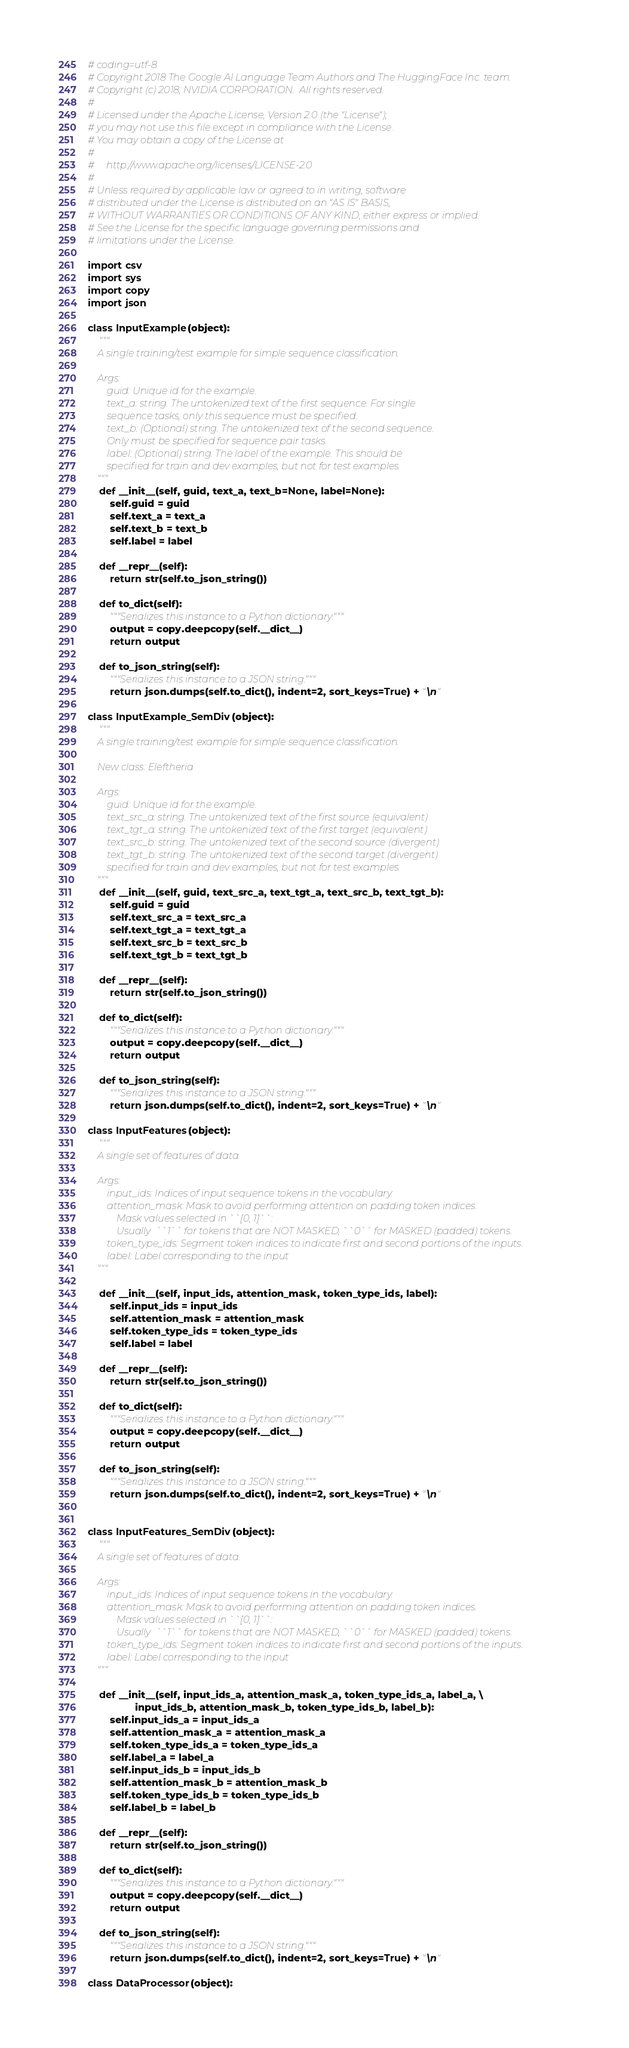<code> <loc_0><loc_0><loc_500><loc_500><_Python_># coding=utf-8
# Copyright 2018 The Google AI Language Team Authors and The HuggingFace Inc. team.
# Copyright (c) 2018, NVIDIA CORPORATION.  All rights reserved.
#
# Licensed under the Apache License, Version 2.0 (the "License");
# you may not use this file except in compliance with the License.
# You may obtain a copy of the License at
#
#     http://www.apache.org/licenses/LICENSE-2.0
#
# Unless required by applicable law or agreed to in writing, software
# distributed under the License is distributed on an "AS IS" BASIS,
# WITHOUT WARRANTIES OR CONDITIONS OF ANY KIND, either express or implied.
# See the License for the specific language governing permissions and
# limitations under the License.

import csv
import sys
import copy
import json

class InputExample(object):
    """
    A single training/test example for simple sequence classification.

    Args:
        guid: Unique id for the example.
        text_a: string. The untokenized text of the first sequence. For single
        sequence tasks, only this sequence must be specified.
        text_b: (Optional) string. The untokenized text of the second sequence.
        Only must be specified for sequence pair tasks.
        label: (Optional) string. The label of the example. This should be
        specified for train and dev examples, but not for test examples.
    """
    def __init__(self, guid, text_a, text_b=None, label=None):
        self.guid = guid
        self.text_a = text_a
        self.text_b = text_b
        self.label = label

    def __repr__(self):
        return str(self.to_json_string())

    def to_dict(self):
        """Serializes this instance to a Python dictionary."""
        output = copy.deepcopy(self.__dict__)
        return output

    def to_json_string(self):
        """Serializes this instance to a JSON string."""
        return json.dumps(self.to_dict(), indent=2, sort_keys=True) + "\n"

class InputExample_SemDiv(object):
    """
    A single training/test example for simple sequence classification.

    New class: Eleftheria

    Args:
        guid: Unique id for the example.
        text_src_a: string. The untokenized text of the first source (equivalent)
        text_tgt_a: string. The untokenized text of the first target (equivalent)
        text_src_b: string. The untokenized text of the second source (divergent)
        text_tgt_b: string. The untokenized text of the second target (divergent)
        specified for train and dev examples, but not for test examples.
    """
    def __init__(self, guid, text_src_a, text_tgt_a, text_src_b, text_tgt_b):
        self.guid = guid
        self.text_src_a = text_src_a
        self.text_tgt_a = text_tgt_a
        self.text_src_b = text_src_b
        self.text_tgt_b = text_tgt_b

    def __repr__(self):
        return str(self.to_json_string())

    def to_dict(self):
        """Serializes this instance to a Python dictionary."""
        output = copy.deepcopy(self.__dict__)
        return output

    def to_json_string(self):
        """Serializes this instance to a JSON string."""
        return json.dumps(self.to_dict(), indent=2, sort_keys=True) + "\n"

class InputFeatures(object):
    """
    A single set of features of data.

    Args:
        input_ids: Indices of input sequence tokens in the vocabulary.
        attention_mask: Mask to avoid performing attention on padding token indices.
            Mask values selected in ``[0, 1]``:
            Usually  ``1`` for tokens that are NOT MASKED, ``0`` for MASKED (padded) tokens.
        token_type_ids: Segment token indices to indicate first and second portions of the inputs.
        label: Label corresponding to the input
    """

    def __init__(self, input_ids, attention_mask, token_type_ids, label):
        self.input_ids = input_ids
        self.attention_mask = attention_mask
        self.token_type_ids = token_type_ids
        self.label = label

    def __repr__(self):
        return str(self.to_json_string())

    def to_dict(self):
        """Serializes this instance to a Python dictionary."""
        output = copy.deepcopy(self.__dict__)
        return output

    def to_json_string(self):
        """Serializes this instance to a JSON string."""
        return json.dumps(self.to_dict(), indent=2, sort_keys=True) + "\n"


class InputFeatures_SemDiv(object):
    """
    A single set of features of data.

    Args:
        input_ids: Indices of input sequence tokens in the vocabulary.
        attention_mask: Mask to avoid performing attention on padding token indices.
            Mask values selected in ``[0, 1]``:
            Usually  ``1`` for tokens that are NOT MASKED, ``0`` for MASKED (padded) tokens.
        token_type_ids: Segment token indices to indicate first and second portions of the inputs.
        label: Label corresponding to the input
    """

    def __init__(self, input_ids_a, attention_mask_a, token_type_ids_a, label_a, \
                 input_ids_b, attention_mask_b, token_type_ids_b, label_b):
        self.input_ids_a = input_ids_a
        self.attention_mask_a = attention_mask_a
        self.token_type_ids_a = token_type_ids_a
        self.label_a = label_a
        self.input_ids_b = input_ids_b
        self.attention_mask_b = attention_mask_b
        self.token_type_ids_b = token_type_ids_b
        self.label_b = label_b

    def __repr__(self):
        return str(self.to_json_string())

    def to_dict(self):
        """Serializes this instance to a Python dictionary."""
        output = copy.deepcopy(self.__dict__)
        return output

    def to_json_string(self):
        """Serializes this instance to a JSON string."""
        return json.dumps(self.to_dict(), indent=2, sort_keys=True) + "\n"

class DataProcessor(object):</code> 